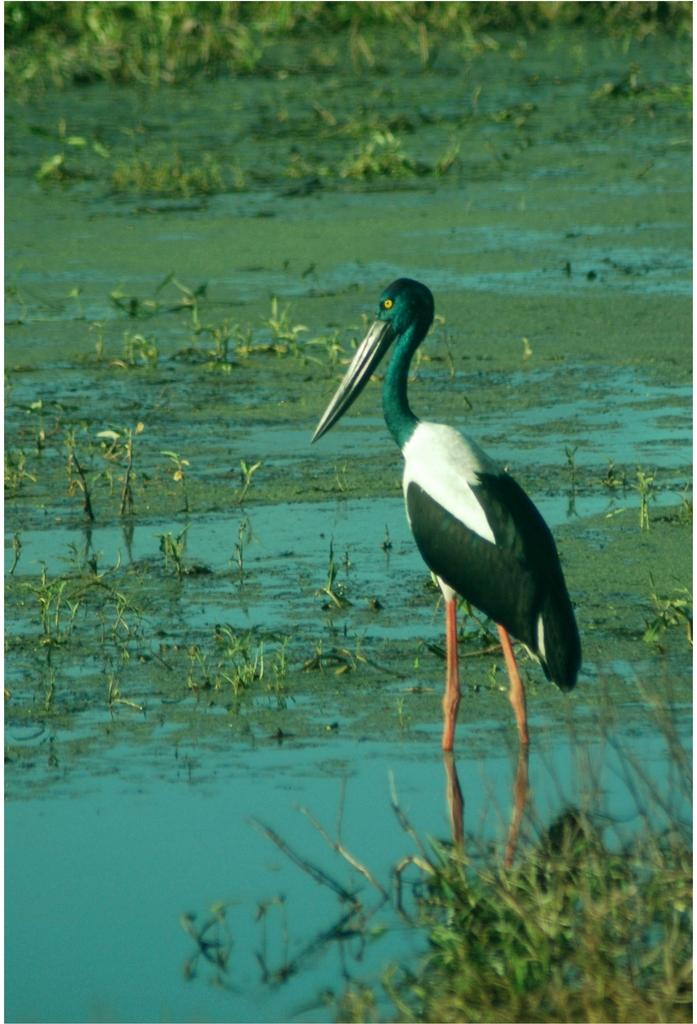Where was the image taken? The image was taken outdoors. What can be seen at the bottom of the image? There is a pond with water and grass at the bottom of the image. What is located on the right side of the image? There is a crane on the right side of the image. What type of bear can be seen playing with a toy in the image? There is no bear or toy present in the image. 